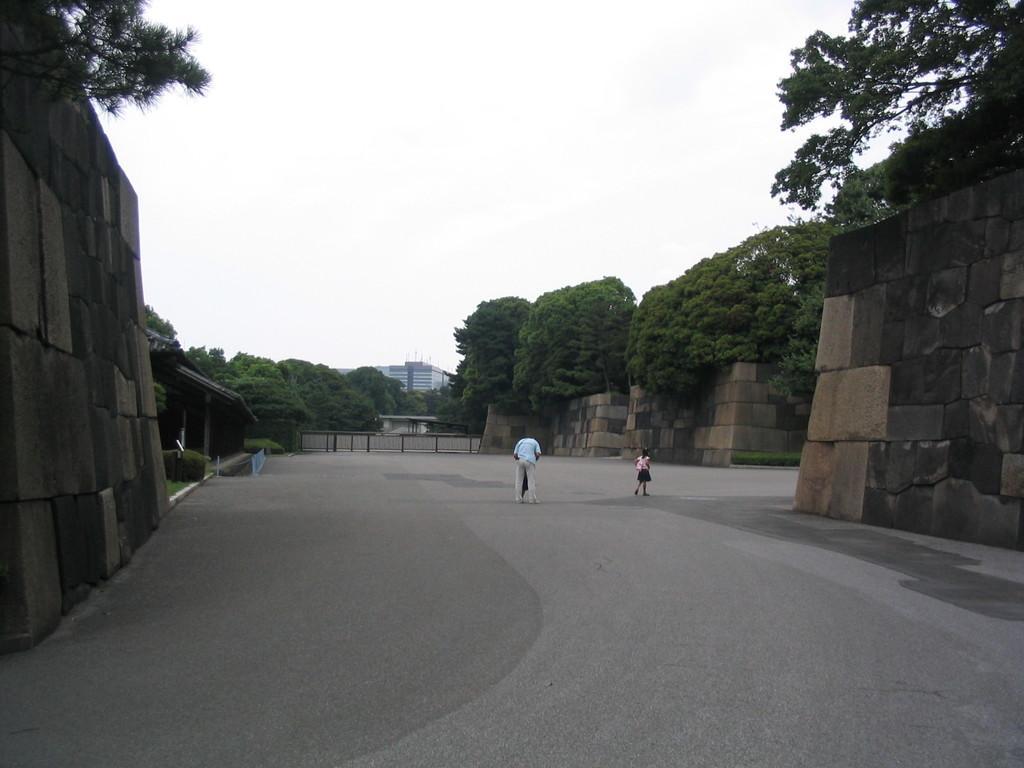Describe this image in one or two sentences. There are two persons on the road. Here we can see wall, fence, plants, trees, and a building. In the background there is sky. 